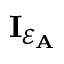Convert formula to latex. <formula><loc_0><loc_0><loc_500><loc_500>I _ { \mathcal { E } _ { A } }</formula> 